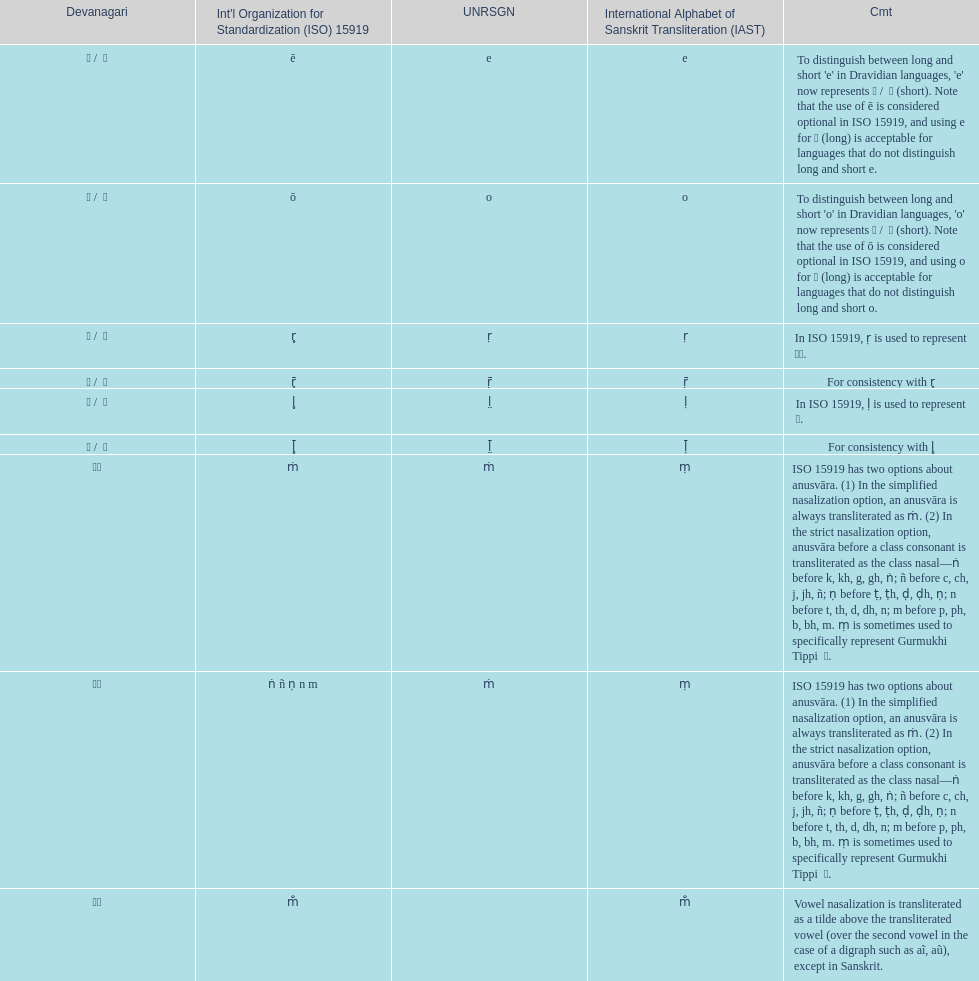What is the total number of translations? 8. 